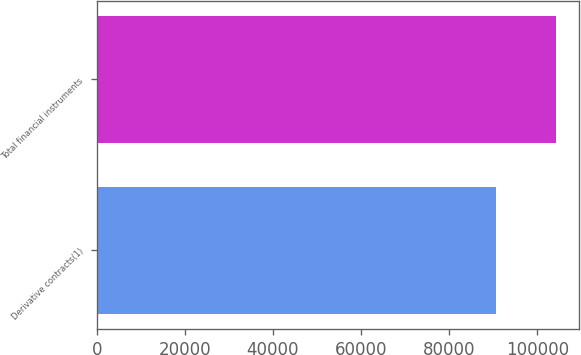Convert chart. <chart><loc_0><loc_0><loc_500><loc_500><bar_chart><fcel>Derivative contracts(1)<fcel>Total financial instruments<nl><fcel>90654<fcel>104181<nl></chart> 